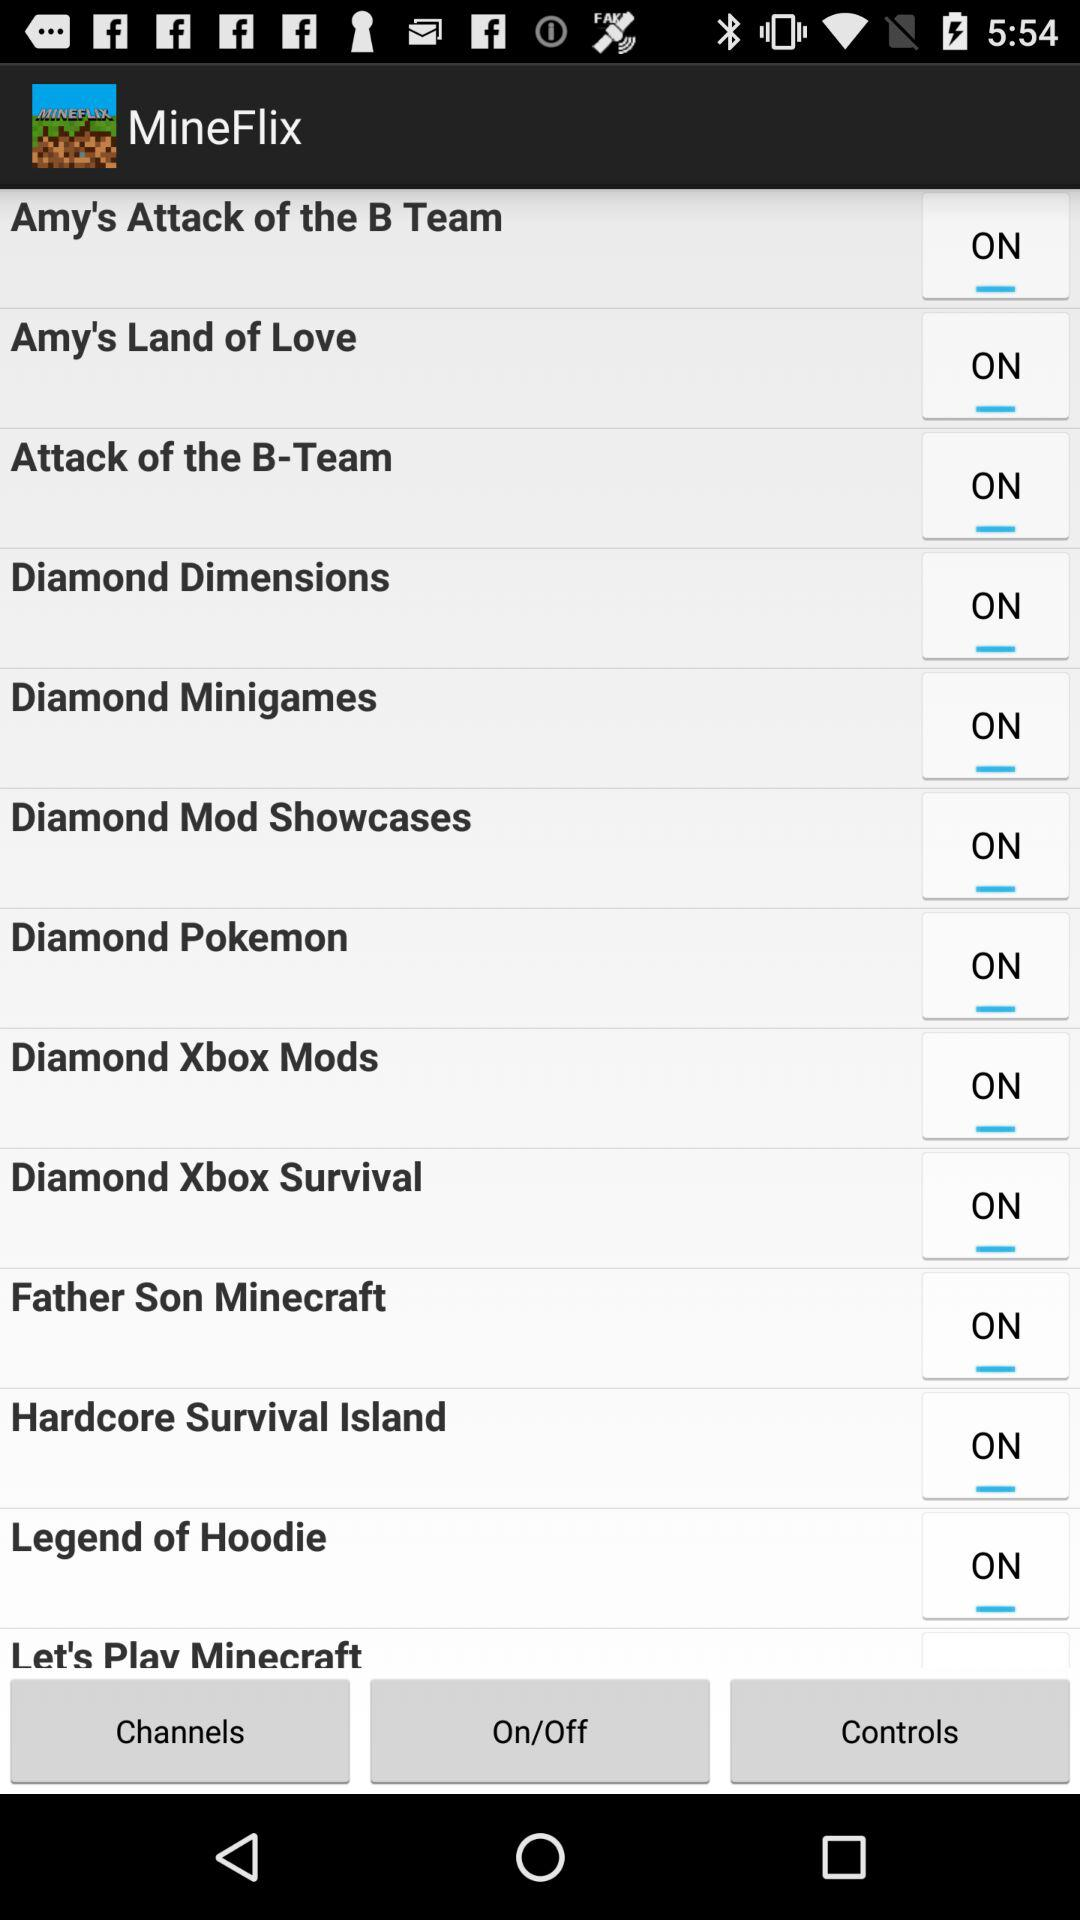What is the status of the "Diamond Dimensions"? The status of the "Diamond Dimensions" is "on". 